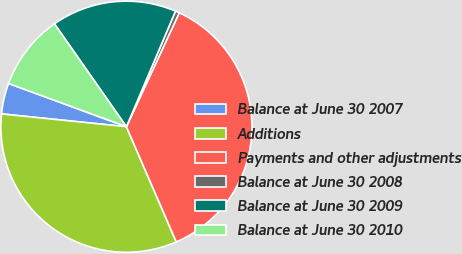Convert chart. <chart><loc_0><loc_0><loc_500><loc_500><pie_chart><fcel>Balance at June 30 2007<fcel>Additions<fcel>Payments and other adjustments<fcel>Balance at June 30 2008<fcel>Balance at June 30 2009<fcel>Balance at June 30 2010<nl><fcel>3.97%<fcel>33.13%<fcel>36.58%<fcel>0.52%<fcel>16.11%<fcel>9.69%<nl></chart> 